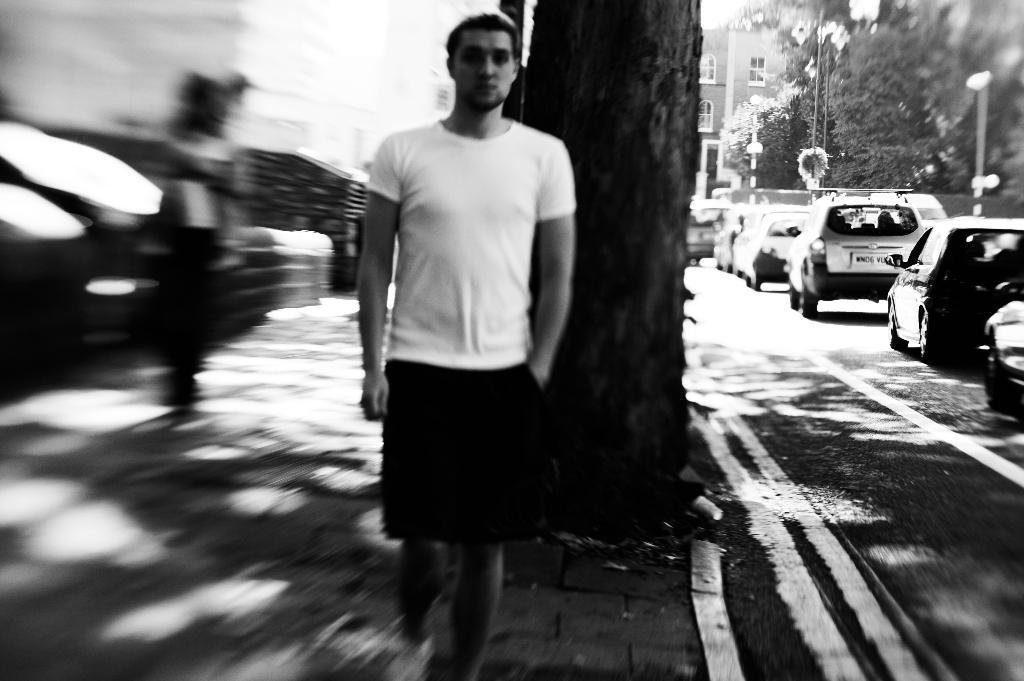Who is the main subject in the front of the image? There is a man in the front of the image. What can be seen on the right side of the image? There are cars, trees, a building, and a pole on the right side of the image. What is the condition of the background in the image? The background of the image is blurry. What is the color scheme of the image? The image is black and white. Can you see any veins in the image? There are no visible veins in the image, as it features a man, cars, trees, a building, and a pole in a black and white, blurry background. 